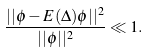Convert formula to latex. <formula><loc_0><loc_0><loc_500><loc_500>\frac { | | \phi - E ( \Delta ) \phi | | ^ { 2 } } { | | \phi | | ^ { 2 } } \ll 1 .</formula> 